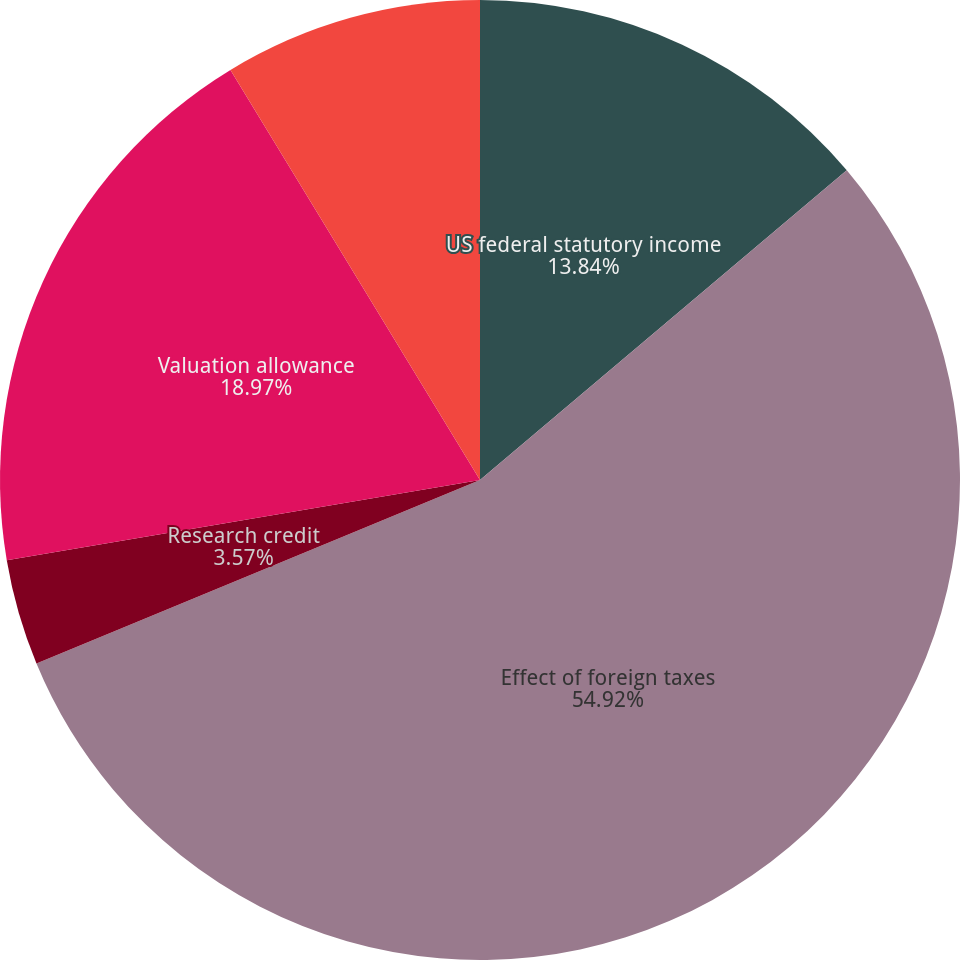Convert chart. <chart><loc_0><loc_0><loc_500><loc_500><pie_chart><fcel>US federal statutory income<fcel>Effect of foreign taxes<fcel>Research credit<fcel>Valuation allowance<fcel>Other net<nl><fcel>13.84%<fcel>54.91%<fcel>3.57%<fcel>18.97%<fcel>8.7%<nl></chart> 